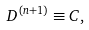Convert formula to latex. <formula><loc_0><loc_0><loc_500><loc_500>D ^ { ( n + 1 ) } \equiv C ,</formula> 